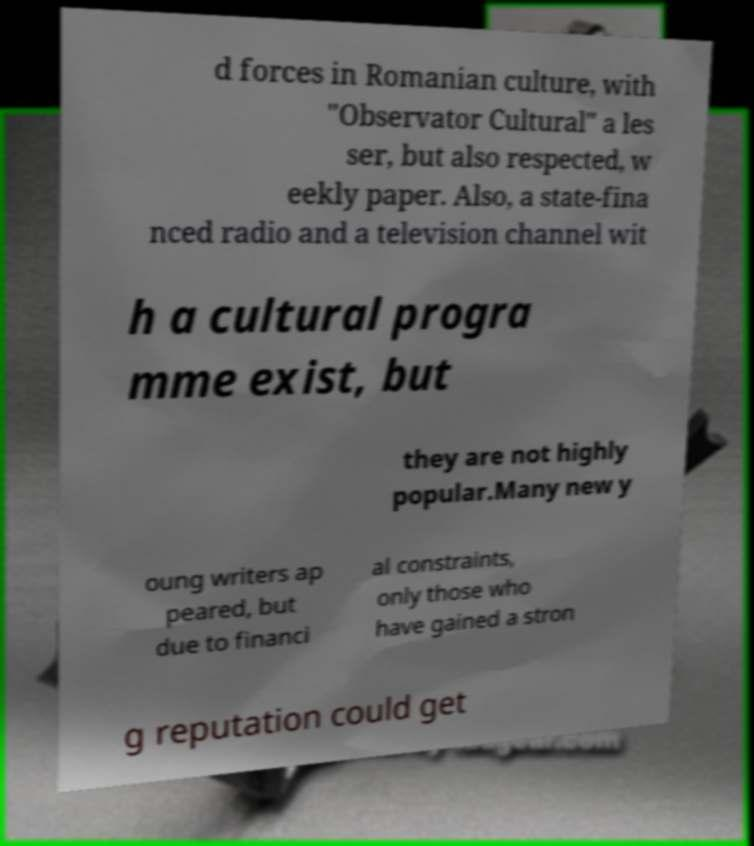Can you read and provide the text displayed in the image?This photo seems to have some interesting text. Can you extract and type it out for me? d forces in Romanian culture, with "Observator Cultural" a les ser, but also respected, w eekly paper. Also, a state-fina nced radio and a television channel wit h a cultural progra mme exist, but they are not highly popular.Many new y oung writers ap peared, but due to financi al constraints, only those who have gained a stron g reputation could get 